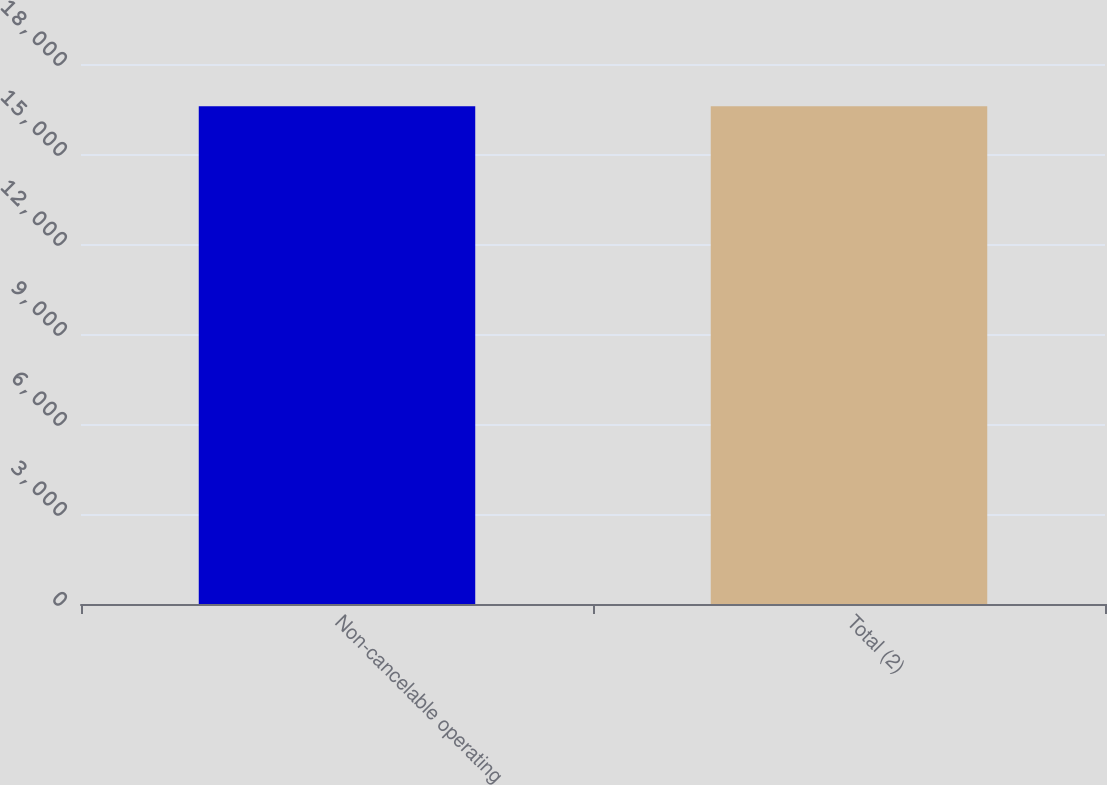Convert chart. <chart><loc_0><loc_0><loc_500><loc_500><bar_chart><fcel>Non-cancelable operating<fcel>Total (2)<nl><fcel>16592<fcel>16592.1<nl></chart> 